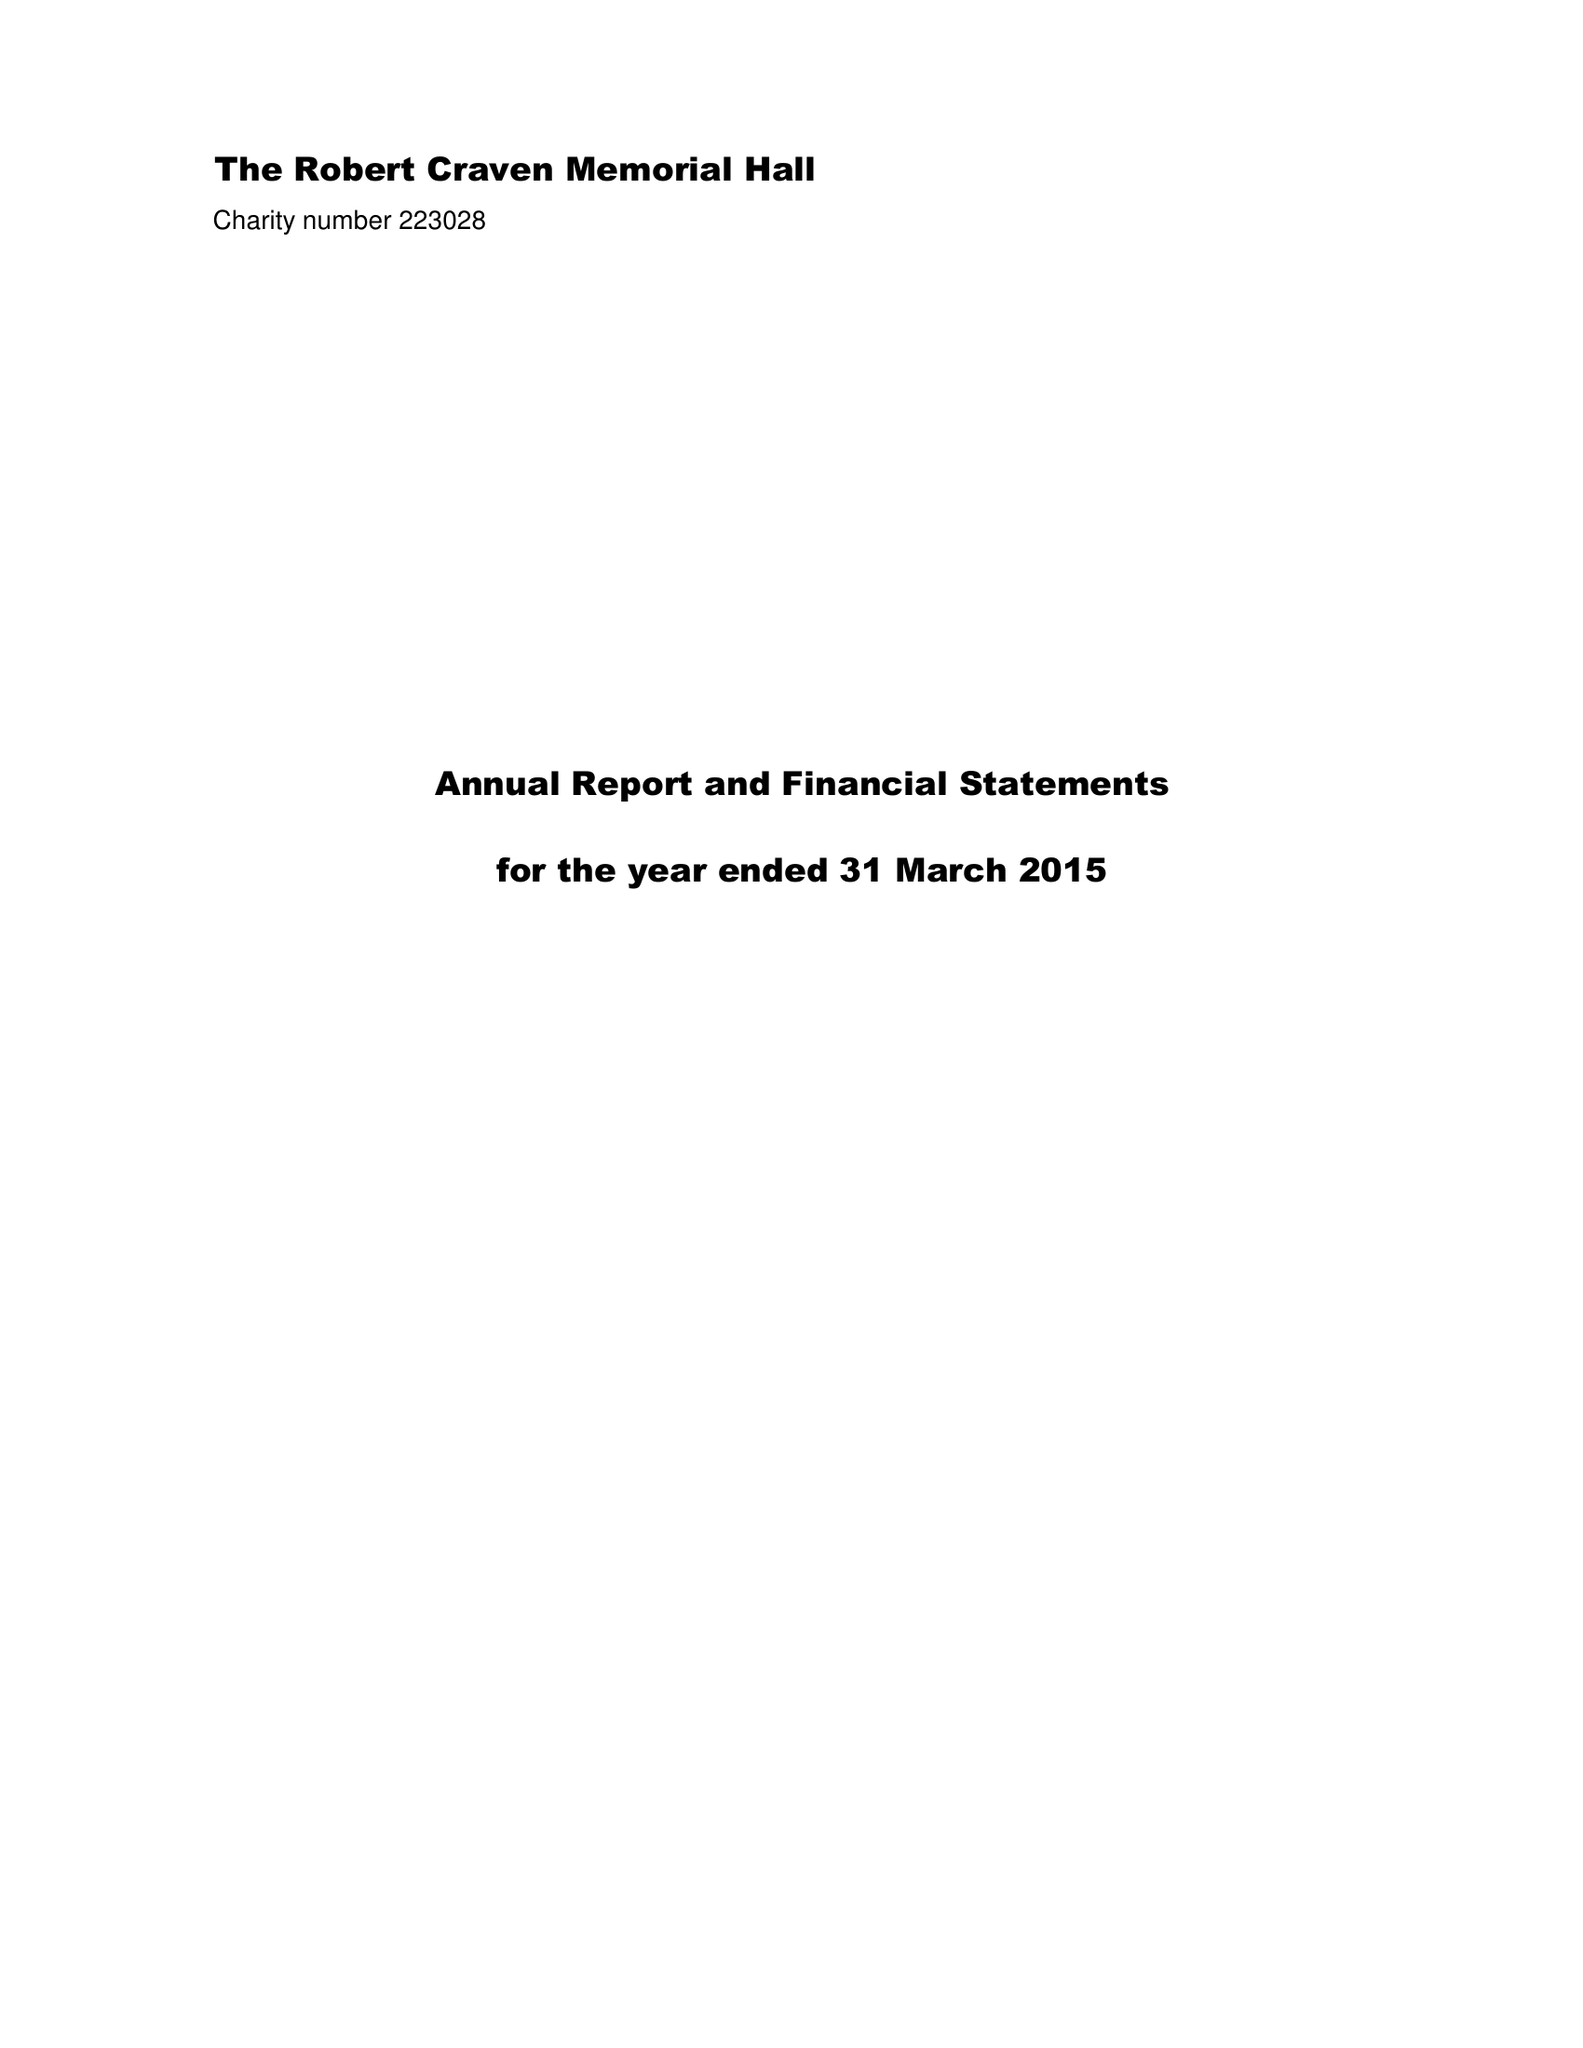What is the value for the address__postcode?
Answer the question using a single word or phrase. LS16 9HJ 